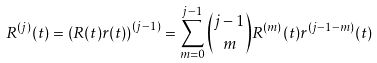<formula> <loc_0><loc_0><loc_500><loc_500>R ^ { ( j ) } ( t ) = \left ( R ( t ) r ( t ) \right ) ^ { ( j - 1 ) } = \sum _ { m = 0 } ^ { j - 1 } \binom { j - 1 } m R ^ { ( m ) } ( t ) r ^ { ( j - 1 - m ) } ( t )</formula> 